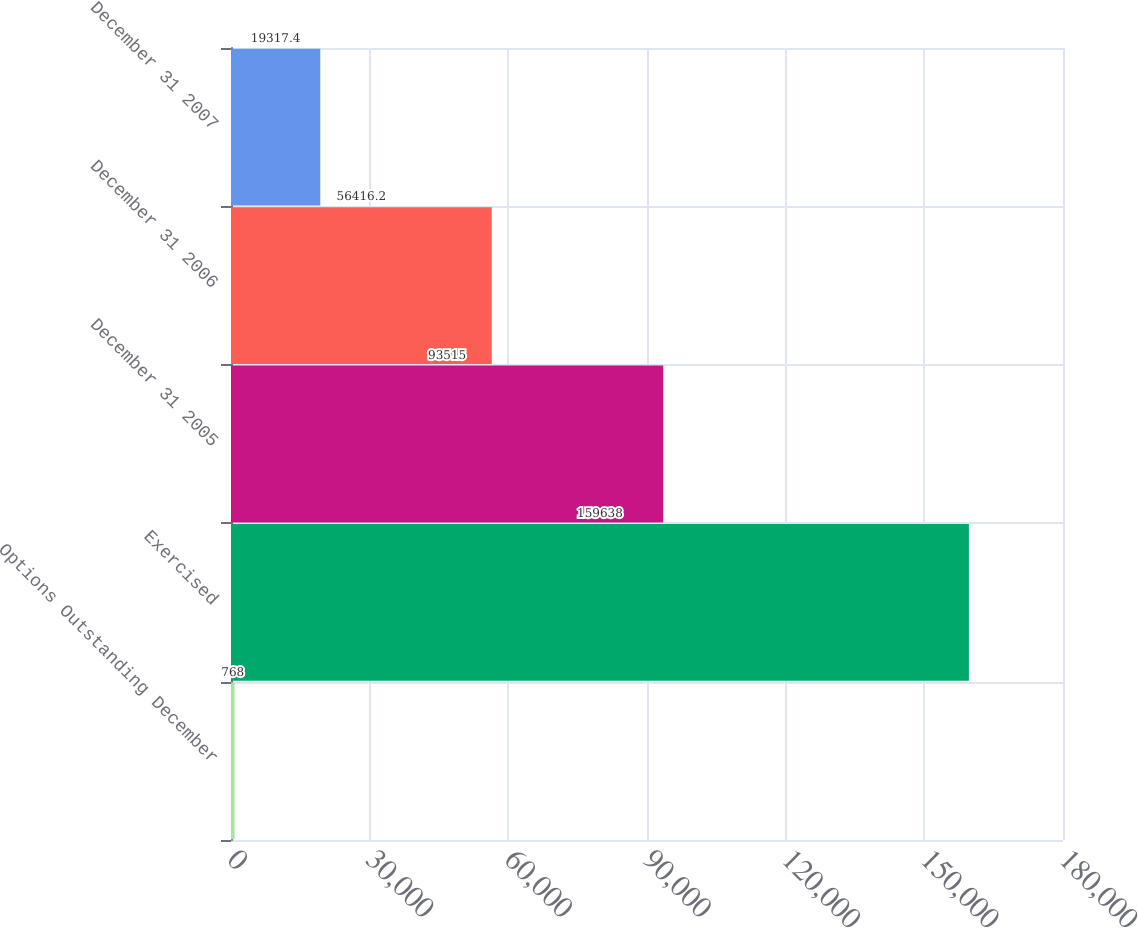Convert chart. <chart><loc_0><loc_0><loc_500><loc_500><bar_chart><fcel>Options Outstanding December<fcel>Exercised<fcel>December 31 2005<fcel>December 31 2006<fcel>December 31 2007<nl><fcel>768<fcel>159638<fcel>93515<fcel>56416.2<fcel>19317.4<nl></chart> 